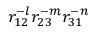Convert formula to latex. <formula><loc_0><loc_0><loc_500><loc_500>r _ { 1 2 } ^ { - l } r _ { 2 3 } ^ { - m } r _ { 3 1 } ^ { - n }</formula> 